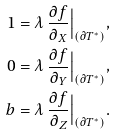Convert formula to latex. <formula><loc_0><loc_0><loc_500><loc_500>1 & = \lambda \ \frac { \partial f } { \partial _ { X } } \Big | _ { ( \partial T ^ { * } ) } , \\ 0 & = \lambda \ \frac { \partial f } { \partial _ { Y } } \Big | _ { ( \partial T ^ { * } ) } , \\ b & = \lambda \ \frac { \partial f } { \partial _ { Z } } \Big | _ { ( \partial T ^ { * } ) } .</formula> 